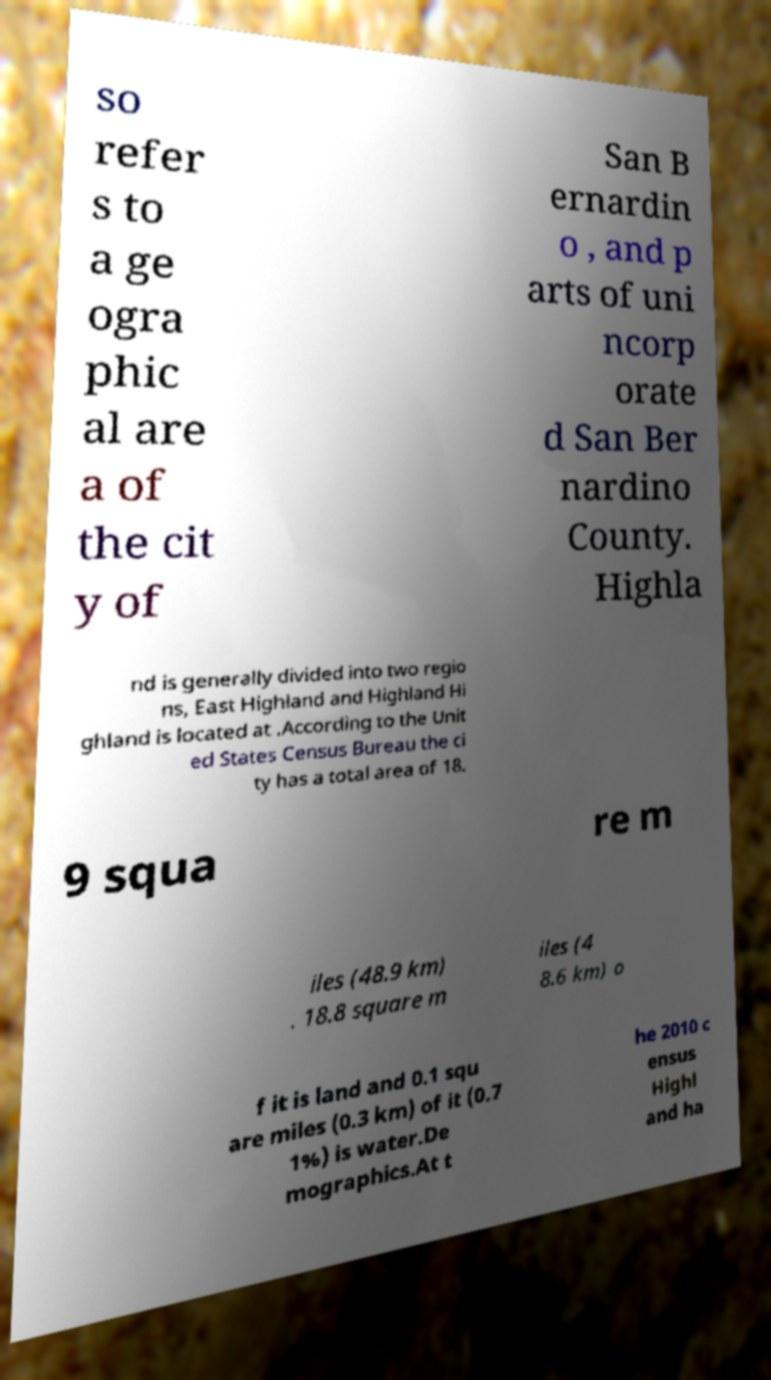Can you read and provide the text displayed in the image?This photo seems to have some interesting text. Can you extract and type it out for me? so refer s to a ge ogra phic al are a of the cit y of San B ernardin o , and p arts of uni ncorp orate d San Ber nardino County. Highla nd is generally divided into two regio ns, East Highland and Highland Hi ghland is located at .According to the Unit ed States Census Bureau the ci ty has a total area of 18. 9 squa re m iles (48.9 km) . 18.8 square m iles (4 8.6 km) o f it is land and 0.1 squ are miles (0.3 km) of it (0.7 1%) is water.De mographics.At t he 2010 c ensus Highl and ha 